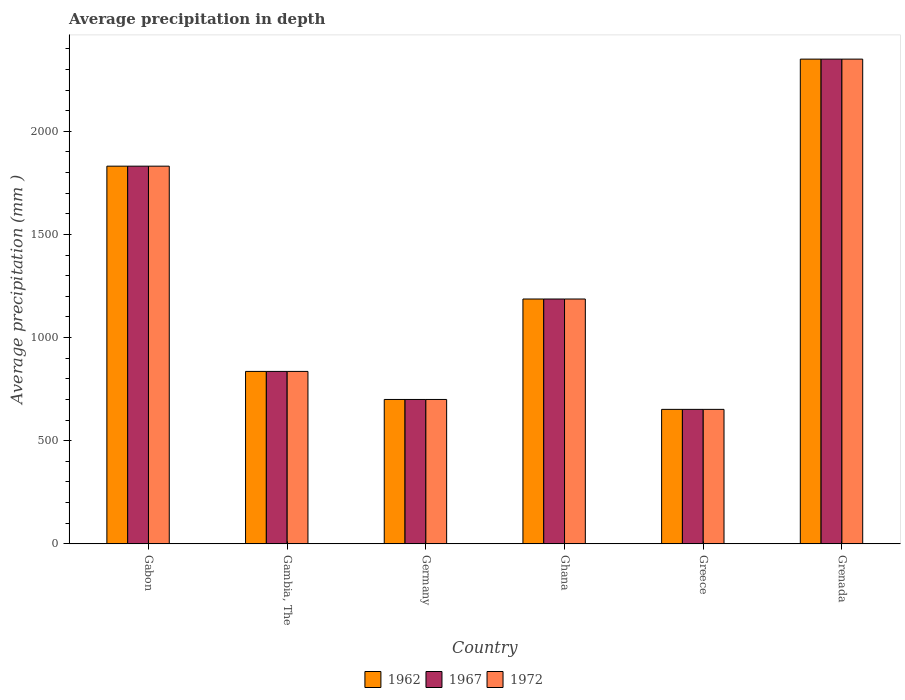How many bars are there on the 1st tick from the left?
Offer a very short reply. 3. How many bars are there on the 1st tick from the right?
Offer a terse response. 3. What is the label of the 3rd group of bars from the left?
Provide a short and direct response. Germany. In how many cases, is the number of bars for a given country not equal to the number of legend labels?
Offer a very short reply. 0. What is the average precipitation in 1972 in Gambia, The?
Ensure brevity in your answer.  836. Across all countries, what is the maximum average precipitation in 1962?
Make the answer very short. 2350. Across all countries, what is the minimum average precipitation in 1967?
Make the answer very short. 652. In which country was the average precipitation in 1967 maximum?
Keep it short and to the point. Grenada. What is the total average precipitation in 1967 in the graph?
Your answer should be very brief. 7556. What is the difference between the average precipitation in 1962 in Greece and that in Grenada?
Provide a succinct answer. -1698. What is the difference between the average precipitation in 1962 in Ghana and the average precipitation in 1967 in Germany?
Provide a succinct answer. 487. What is the average average precipitation in 1972 per country?
Keep it short and to the point. 1259.33. In how many countries, is the average precipitation in 1962 greater than 900 mm?
Offer a very short reply. 3. What is the ratio of the average precipitation in 1962 in Gambia, The to that in Ghana?
Keep it short and to the point. 0.7. Is the average precipitation in 1962 in Gabon less than that in Germany?
Keep it short and to the point. No. What is the difference between the highest and the second highest average precipitation in 1967?
Provide a short and direct response. -1163. What is the difference between the highest and the lowest average precipitation in 1962?
Provide a succinct answer. 1698. What does the 3rd bar from the right in Grenada represents?
Your answer should be compact. 1962. Is it the case that in every country, the sum of the average precipitation in 1962 and average precipitation in 1967 is greater than the average precipitation in 1972?
Your answer should be compact. Yes. How many countries are there in the graph?
Offer a terse response. 6. Are the values on the major ticks of Y-axis written in scientific E-notation?
Offer a very short reply. No. Where does the legend appear in the graph?
Your answer should be very brief. Bottom center. What is the title of the graph?
Offer a very short reply. Average precipitation in depth. What is the label or title of the Y-axis?
Ensure brevity in your answer.  Average precipitation (mm ). What is the Average precipitation (mm ) of 1962 in Gabon?
Provide a short and direct response. 1831. What is the Average precipitation (mm ) of 1967 in Gabon?
Offer a terse response. 1831. What is the Average precipitation (mm ) in 1972 in Gabon?
Offer a very short reply. 1831. What is the Average precipitation (mm ) of 1962 in Gambia, The?
Offer a very short reply. 836. What is the Average precipitation (mm ) in 1967 in Gambia, The?
Your answer should be compact. 836. What is the Average precipitation (mm ) in 1972 in Gambia, The?
Keep it short and to the point. 836. What is the Average precipitation (mm ) in 1962 in Germany?
Your answer should be compact. 700. What is the Average precipitation (mm ) of 1967 in Germany?
Provide a succinct answer. 700. What is the Average precipitation (mm ) in 1972 in Germany?
Ensure brevity in your answer.  700. What is the Average precipitation (mm ) of 1962 in Ghana?
Your response must be concise. 1187. What is the Average precipitation (mm ) of 1967 in Ghana?
Make the answer very short. 1187. What is the Average precipitation (mm ) in 1972 in Ghana?
Give a very brief answer. 1187. What is the Average precipitation (mm ) of 1962 in Greece?
Give a very brief answer. 652. What is the Average precipitation (mm ) of 1967 in Greece?
Your answer should be very brief. 652. What is the Average precipitation (mm ) in 1972 in Greece?
Offer a terse response. 652. What is the Average precipitation (mm ) in 1962 in Grenada?
Make the answer very short. 2350. What is the Average precipitation (mm ) in 1967 in Grenada?
Keep it short and to the point. 2350. What is the Average precipitation (mm ) of 1972 in Grenada?
Offer a terse response. 2350. Across all countries, what is the maximum Average precipitation (mm ) in 1962?
Provide a succinct answer. 2350. Across all countries, what is the maximum Average precipitation (mm ) in 1967?
Provide a short and direct response. 2350. Across all countries, what is the maximum Average precipitation (mm ) in 1972?
Make the answer very short. 2350. Across all countries, what is the minimum Average precipitation (mm ) of 1962?
Keep it short and to the point. 652. Across all countries, what is the minimum Average precipitation (mm ) of 1967?
Give a very brief answer. 652. Across all countries, what is the minimum Average precipitation (mm ) of 1972?
Keep it short and to the point. 652. What is the total Average precipitation (mm ) of 1962 in the graph?
Your response must be concise. 7556. What is the total Average precipitation (mm ) of 1967 in the graph?
Give a very brief answer. 7556. What is the total Average precipitation (mm ) of 1972 in the graph?
Keep it short and to the point. 7556. What is the difference between the Average precipitation (mm ) of 1962 in Gabon and that in Gambia, The?
Provide a succinct answer. 995. What is the difference between the Average precipitation (mm ) in 1967 in Gabon and that in Gambia, The?
Provide a succinct answer. 995. What is the difference between the Average precipitation (mm ) in 1972 in Gabon and that in Gambia, The?
Make the answer very short. 995. What is the difference between the Average precipitation (mm ) of 1962 in Gabon and that in Germany?
Give a very brief answer. 1131. What is the difference between the Average precipitation (mm ) in 1967 in Gabon and that in Germany?
Your answer should be very brief. 1131. What is the difference between the Average precipitation (mm ) of 1972 in Gabon and that in Germany?
Provide a short and direct response. 1131. What is the difference between the Average precipitation (mm ) of 1962 in Gabon and that in Ghana?
Your answer should be very brief. 644. What is the difference between the Average precipitation (mm ) of 1967 in Gabon and that in Ghana?
Your response must be concise. 644. What is the difference between the Average precipitation (mm ) in 1972 in Gabon and that in Ghana?
Offer a terse response. 644. What is the difference between the Average precipitation (mm ) of 1962 in Gabon and that in Greece?
Offer a very short reply. 1179. What is the difference between the Average precipitation (mm ) in 1967 in Gabon and that in Greece?
Offer a terse response. 1179. What is the difference between the Average precipitation (mm ) of 1972 in Gabon and that in Greece?
Offer a very short reply. 1179. What is the difference between the Average precipitation (mm ) in 1962 in Gabon and that in Grenada?
Ensure brevity in your answer.  -519. What is the difference between the Average precipitation (mm ) of 1967 in Gabon and that in Grenada?
Provide a succinct answer. -519. What is the difference between the Average precipitation (mm ) in 1972 in Gabon and that in Grenada?
Make the answer very short. -519. What is the difference between the Average precipitation (mm ) in 1962 in Gambia, The and that in Germany?
Give a very brief answer. 136. What is the difference between the Average precipitation (mm ) in 1967 in Gambia, The and that in Germany?
Offer a terse response. 136. What is the difference between the Average precipitation (mm ) in 1972 in Gambia, The and that in Germany?
Keep it short and to the point. 136. What is the difference between the Average precipitation (mm ) of 1962 in Gambia, The and that in Ghana?
Offer a very short reply. -351. What is the difference between the Average precipitation (mm ) in 1967 in Gambia, The and that in Ghana?
Offer a terse response. -351. What is the difference between the Average precipitation (mm ) of 1972 in Gambia, The and that in Ghana?
Your answer should be very brief. -351. What is the difference between the Average precipitation (mm ) in 1962 in Gambia, The and that in Greece?
Your answer should be compact. 184. What is the difference between the Average precipitation (mm ) of 1967 in Gambia, The and that in Greece?
Your answer should be very brief. 184. What is the difference between the Average precipitation (mm ) of 1972 in Gambia, The and that in Greece?
Keep it short and to the point. 184. What is the difference between the Average precipitation (mm ) of 1962 in Gambia, The and that in Grenada?
Provide a short and direct response. -1514. What is the difference between the Average precipitation (mm ) of 1967 in Gambia, The and that in Grenada?
Keep it short and to the point. -1514. What is the difference between the Average precipitation (mm ) of 1972 in Gambia, The and that in Grenada?
Offer a terse response. -1514. What is the difference between the Average precipitation (mm ) in 1962 in Germany and that in Ghana?
Give a very brief answer. -487. What is the difference between the Average precipitation (mm ) in 1967 in Germany and that in Ghana?
Keep it short and to the point. -487. What is the difference between the Average precipitation (mm ) in 1972 in Germany and that in Ghana?
Your answer should be very brief. -487. What is the difference between the Average precipitation (mm ) of 1962 in Germany and that in Greece?
Make the answer very short. 48. What is the difference between the Average precipitation (mm ) in 1972 in Germany and that in Greece?
Provide a short and direct response. 48. What is the difference between the Average precipitation (mm ) of 1962 in Germany and that in Grenada?
Your response must be concise. -1650. What is the difference between the Average precipitation (mm ) of 1967 in Germany and that in Grenada?
Make the answer very short. -1650. What is the difference between the Average precipitation (mm ) in 1972 in Germany and that in Grenada?
Keep it short and to the point. -1650. What is the difference between the Average precipitation (mm ) of 1962 in Ghana and that in Greece?
Ensure brevity in your answer.  535. What is the difference between the Average precipitation (mm ) of 1967 in Ghana and that in Greece?
Give a very brief answer. 535. What is the difference between the Average precipitation (mm ) in 1972 in Ghana and that in Greece?
Ensure brevity in your answer.  535. What is the difference between the Average precipitation (mm ) in 1962 in Ghana and that in Grenada?
Provide a short and direct response. -1163. What is the difference between the Average precipitation (mm ) of 1967 in Ghana and that in Grenada?
Offer a terse response. -1163. What is the difference between the Average precipitation (mm ) of 1972 in Ghana and that in Grenada?
Give a very brief answer. -1163. What is the difference between the Average precipitation (mm ) of 1962 in Greece and that in Grenada?
Your response must be concise. -1698. What is the difference between the Average precipitation (mm ) of 1967 in Greece and that in Grenada?
Give a very brief answer. -1698. What is the difference between the Average precipitation (mm ) in 1972 in Greece and that in Grenada?
Your answer should be very brief. -1698. What is the difference between the Average precipitation (mm ) in 1962 in Gabon and the Average precipitation (mm ) in 1967 in Gambia, The?
Offer a very short reply. 995. What is the difference between the Average precipitation (mm ) in 1962 in Gabon and the Average precipitation (mm ) in 1972 in Gambia, The?
Provide a short and direct response. 995. What is the difference between the Average precipitation (mm ) in 1967 in Gabon and the Average precipitation (mm ) in 1972 in Gambia, The?
Provide a succinct answer. 995. What is the difference between the Average precipitation (mm ) in 1962 in Gabon and the Average precipitation (mm ) in 1967 in Germany?
Make the answer very short. 1131. What is the difference between the Average precipitation (mm ) of 1962 in Gabon and the Average precipitation (mm ) of 1972 in Germany?
Give a very brief answer. 1131. What is the difference between the Average precipitation (mm ) of 1967 in Gabon and the Average precipitation (mm ) of 1972 in Germany?
Provide a succinct answer. 1131. What is the difference between the Average precipitation (mm ) in 1962 in Gabon and the Average precipitation (mm ) in 1967 in Ghana?
Provide a short and direct response. 644. What is the difference between the Average precipitation (mm ) of 1962 in Gabon and the Average precipitation (mm ) of 1972 in Ghana?
Offer a terse response. 644. What is the difference between the Average precipitation (mm ) of 1967 in Gabon and the Average precipitation (mm ) of 1972 in Ghana?
Provide a succinct answer. 644. What is the difference between the Average precipitation (mm ) of 1962 in Gabon and the Average precipitation (mm ) of 1967 in Greece?
Your answer should be compact. 1179. What is the difference between the Average precipitation (mm ) of 1962 in Gabon and the Average precipitation (mm ) of 1972 in Greece?
Give a very brief answer. 1179. What is the difference between the Average precipitation (mm ) of 1967 in Gabon and the Average precipitation (mm ) of 1972 in Greece?
Your answer should be very brief. 1179. What is the difference between the Average precipitation (mm ) in 1962 in Gabon and the Average precipitation (mm ) in 1967 in Grenada?
Provide a short and direct response. -519. What is the difference between the Average precipitation (mm ) of 1962 in Gabon and the Average precipitation (mm ) of 1972 in Grenada?
Give a very brief answer. -519. What is the difference between the Average precipitation (mm ) of 1967 in Gabon and the Average precipitation (mm ) of 1972 in Grenada?
Give a very brief answer. -519. What is the difference between the Average precipitation (mm ) in 1962 in Gambia, The and the Average precipitation (mm ) in 1967 in Germany?
Provide a succinct answer. 136. What is the difference between the Average precipitation (mm ) of 1962 in Gambia, The and the Average precipitation (mm ) of 1972 in Germany?
Your answer should be compact. 136. What is the difference between the Average precipitation (mm ) in 1967 in Gambia, The and the Average precipitation (mm ) in 1972 in Germany?
Make the answer very short. 136. What is the difference between the Average precipitation (mm ) of 1962 in Gambia, The and the Average precipitation (mm ) of 1967 in Ghana?
Your response must be concise. -351. What is the difference between the Average precipitation (mm ) in 1962 in Gambia, The and the Average precipitation (mm ) in 1972 in Ghana?
Your answer should be very brief. -351. What is the difference between the Average precipitation (mm ) in 1967 in Gambia, The and the Average precipitation (mm ) in 1972 in Ghana?
Make the answer very short. -351. What is the difference between the Average precipitation (mm ) in 1962 in Gambia, The and the Average precipitation (mm ) in 1967 in Greece?
Your answer should be very brief. 184. What is the difference between the Average precipitation (mm ) of 1962 in Gambia, The and the Average precipitation (mm ) of 1972 in Greece?
Offer a very short reply. 184. What is the difference between the Average precipitation (mm ) of 1967 in Gambia, The and the Average precipitation (mm ) of 1972 in Greece?
Your answer should be compact. 184. What is the difference between the Average precipitation (mm ) of 1962 in Gambia, The and the Average precipitation (mm ) of 1967 in Grenada?
Offer a terse response. -1514. What is the difference between the Average precipitation (mm ) in 1962 in Gambia, The and the Average precipitation (mm ) in 1972 in Grenada?
Give a very brief answer. -1514. What is the difference between the Average precipitation (mm ) in 1967 in Gambia, The and the Average precipitation (mm ) in 1972 in Grenada?
Ensure brevity in your answer.  -1514. What is the difference between the Average precipitation (mm ) of 1962 in Germany and the Average precipitation (mm ) of 1967 in Ghana?
Ensure brevity in your answer.  -487. What is the difference between the Average precipitation (mm ) of 1962 in Germany and the Average precipitation (mm ) of 1972 in Ghana?
Your response must be concise. -487. What is the difference between the Average precipitation (mm ) in 1967 in Germany and the Average precipitation (mm ) in 1972 in Ghana?
Your response must be concise. -487. What is the difference between the Average precipitation (mm ) of 1962 in Germany and the Average precipitation (mm ) of 1967 in Greece?
Provide a short and direct response. 48. What is the difference between the Average precipitation (mm ) of 1967 in Germany and the Average precipitation (mm ) of 1972 in Greece?
Give a very brief answer. 48. What is the difference between the Average precipitation (mm ) of 1962 in Germany and the Average precipitation (mm ) of 1967 in Grenada?
Provide a succinct answer. -1650. What is the difference between the Average precipitation (mm ) of 1962 in Germany and the Average precipitation (mm ) of 1972 in Grenada?
Your response must be concise. -1650. What is the difference between the Average precipitation (mm ) of 1967 in Germany and the Average precipitation (mm ) of 1972 in Grenada?
Give a very brief answer. -1650. What is the difference between the Average precipitation (mm ) of 1962 in Ghana and the Average precipitation (mm ) of 1967 in Greece?
Your response must be concise. 535. What is the difference between the Average precipitation (mm ) of 1962 in Ghana and the Average precipitation (mm ) of 1972 in Greece?
Keep it short and to the point. 535. What is the difference between the Average precipitation (mm ) in 1967 in Ghana and the Average precipitation (mm ) in 1972 in Greece?
Make the answer very short. 535. What is the difference between the Average precipitation (mm ) in 1962 in Ghana and the Average precipitation (mm ) in 1967 in Grenada?
Offer a terse response. -1163. What is the difference between the Average precipitation (mm ) of 1962 in Ghana and the Average precipitation (mm ) of 1972 in Grenada?
Your answer should be very brief. -1163. What is the difference between the Average precipitation (mm ) in 1967 in Ghana and the Average precipitation (mm ) in 1972 in Grenada?
Provide a short and direct response. -1163. What is the difference between the Average precipitation (mm ) in 1962 in Greece and the Average precipitation (mm ) in 1967 in Grenada?
Provide a short and direct response. -1698. What is the difference between the Average precipitation (mm ) of 1962 in Greece and the Average precipitation (mm ) of 1972 in Grenada?
Give a very brief answer. -1698. What is the difference between the Average precipitation (mm ) of 1967 in Greece and the Average precipitation (mm ) of 1972 in Grenada?
Provide a succinct answer. -1698. What is the average Average precipitation (mm ) in 1962 per country?
Keep it short and to the point. 1259.33. What is the average Average precipitation (mm ) in 1967 per country?
Your response must be concise. 1259.33. What is the average Average precipitation (mm ) in 1972 per country?
Provide a succinct answer. 1259.33. What is the difference between the Average precipitation (mm ) of 1962 and Average precipitation (mm ) of 1967 in Gabon?
Offer a terse response. 0. What is the difference between the Average precipitation (mm ) in 1967 and Average precipitation (mm ) in 1972 in Gabon?
Make the answer very short. 0. What is the difference between the Average precipitation (mm ) of 1962 and Average precipitation (mm ) of 1967 in Gambia, The?
Ensure brevity in your answer.  0. What is the difference between the Average precipitation (mm ) of 1967 and Average precipitation (mm ) of 1972 in Gambia, The?
Ensure brevity in your answer.  0. What is the difference between the Average precipitation (mm ) of 1962 and Average precipitation (mm ) of 1972 in Germany?
Offer a terse response. 0. What is the difference between the Average precipitation (mm ) of 1962 and Average precipitation (mm ) of 1967 in Ghana?
Provide a succinct answer. 0. What is the difference between the Average precipitation (mm ) in 1962 and Average precipitation (mm ) in 1972 in Ghana?
Provide a short and direct response. 0. What is the difference between the Average precipitation (mm ) of 1967 and Average precipitation (mm ) of 1972 in Greece?
Your answer should be compact. 0. What is the difference between the Average precipitation (mm ) of 1962 and Average precipitation (mm ) of 1967 in Grenada?
Your response must be concise. 0. What is the difference between the Average precipitation (mm ) in 1967 and Average precipitation (mm ) in 1972 in Grenada?
Make the answer very short. 0. What is the ratio of the Average precipitation (mm ) in 1962 in Gabon to that in Gambia, The?
Your response must be concise. 2.19. What is the ratio of the Average precipitation (mm ) in 1967 in Gabon to that in Gambia, The?
Provide a short and direct response. 2.19. What is the ratio of the Average precipitation (mm ) of 1972 in Gabon to that in Gambia, The?
Make the answer very short. 2.19. What is the ratio of the Average precipitation (mm ) in 1962 in Gabon to that in Germany?
Your answer should be very brief. 2.62. What is the ratio of the Average precipitation (mm ) of 1967 in Gabon to that in Germany?
Your response must be concise. 2.62. What is the ratio of the Average precipitation (mm ) in 1972 in Gabon to that in Germany?
Your answer should be very brief. 2.62. What is the ratio of the Average precipitation (mm ) in 1962 in Gabon to that in Ghana?
Make the answer very short. 1.54. What is the ratio of the Average precipitation (mm ) in 1967 in Gabon to that in Ghana?
Make the answer very short. 1.54. What is the ratio of the Average precipitation (mm ) of 1972 in Gabon to that in Ghana?
Provide a succinct answer. 1.54. What is the ratio of the Average precipitation (mm ) of 1962 in Gabon to that in Greece?
Make the answer very short. 2.81. What is the ratio of the Average precipitation (mm ) of 1967 in Gabon to that in Greece?
Make the answer very short. 2.81. What is the ratio of the Average precipitation (mm ) in 1972 in Gabon to that in Greece?
Your answer should be compact. 2.81. What is the ratio of the Average precipitation (mm ) of 1962 in Gabon to that in Grenada?
Your answer should be very brief. 0.78. What is the ratio of the Average precipitation (mm ) in 1967 in Gabon to that in Grenada?
Your answer should be very brief. 0.78. What is the ratio of the Average precipitation (mm ) of 1972 in Gabon to that in Grenada?
Provide a short and direct response. 0.78. What is the ratio of the Average precipitation (mm ) in 1962 in Gambia, The to that in Germany?
Make the answer very short. 1.19. What is the ratio of the Average precipitation (mm ) in 1967 in Gambia, The to that in Germany?
Make the answer very short. 1.19. What is the ratio of the Average precipitation (mm ) of 1972 in Gambia, The to that in Germany?
Provide a short and direct response. 1.19. What is the ratio of the Average precipitation (mm ) in 1962 in Gambia, The to that in Ghana?
Your response must be concise. 0.7. What is the ratio of the Average precipitation (mm ) in 1967 in Gambia, The to that in Ghana?
Provide a short and direct response. 0.7. What is the ratio of the Average precipitation (mm ) in 1972 in Gambia, The to that in Ghana?
Ensure brevity in your answer.  0.7. What is the ratio of the Average precipitation (mm ) in 1962 in Gambia, The to that in Greece?
Your answer should be compact. 1.28. What is the ratio of the Average precipitation (mm ) in 1967 in Gambia, The to that in Greece?
Your answer should be compact. 1.28. What is the ratio of the Average precipitation (mm ) of 1972 in Gambia, The to that in Greece?
Give a very brief answer. 1.28. What is the ratio of the Average precipitation (mm ) in 1962 in Gambia, The to that in Grenada?
Give a very brief answer. 0.36. What is the ratio of the Average precipitation (mm ) of 1967 in Gambia, The to that in Grenada?
Offer a very short reply. 0.36. What is the ratio of the Average precipitation (mm ) of 1972 in Gambia, The to that in Grenada?
Keep it short and to the point. 0.36. What is the ratio of the Average precipitation (mm ) of 1962 in Germany to that in Ghana?
Make the answer very short. 0.59. What is the ratio of the Average precipitation (mm ) of 1967 in Germany to that in Ghana?
Your response must be concise. 0.59. What is the ratio of the Average precipitation (mm ) of 1972 in Germany to that in Ghana?
Offer a very short reply. 0.59. What is the ratio of the Average precipitation (mm ) in 1962 in Germany to that in Greece?
Provide a short and direct response. 1.07. What is the ratio of the Average precipitation (mm ) of 1967 in Germany to that in Greece?
Your answer should be compact. 1.07. What is the ratio of the Average precipitation (mm ) in 1972 in Germany to that in Greece?
Offer a terse response. 1.07. What is the ratio of the Average precipitation (mm ) in 1962 in Germany to that in Grenada?
Offer a terse response. 0.3. What is the ratio of the Average precipitation (mm ) in 1967 in Germany to that in Grenada?
Give a very brief answer. 0.3. What is the ratio of the Average precipitation (mm ) of 1972 in Germany to that in Grenada?
Give a very brief answer. 0.3. What is the ratio of the Average precipitation (mm ) in 1962 in Ghana to that in Greece?
Make the answer very short. 1.82. What is the ratio of the Average precipitation (mm ) in 1967 in Ghana to that in Greece?
Your answer should be very brief. 1.82. What is the ratio of the Average precipitation (mm ) in 1972 in Ghana to that in Greece?
Provide a succinct answer. 1.82. What is the ratio of the Average precipitation (mm ) of 1962 in Ghana to that in Grenada?
Provide a succinct answer. 0.51. What is the ratio of the Average precipitation (mm ) of 1967 in Ghana to that in Grenada?
Offer a terse response. 0.51. What is the ratio of the Average precipitation (mm ) in 1972 in Ghana to that in Grenada?
Offer a terse response. 0.51. What is the ratio of the Average precipitation (mm ) of 1962 in Greece to that in Grenada?
Keep it short and to the point. 0.28. What is the ratio of the Average precipitation (mm ) of 1967 in Greece to that in Grenada?
Ensure brevity in your answer.  0.28. What is the ratio of the Average precipitation (mm ) in 1972 in Greece to that in Grenada?
Your answer should be compact. 0.28. What is the difference between the highest and the second highest Average precipitation (mm ) in 1962?
Offer a very short reply. 519. What is the difference between the highest and the second highest Average precipitation (mm ) of 1967?
Make the answer very short. 519. What is the difference between the highest and the second highest Average precipitation (mm ) of 1972?
Give a very brief answer. 519. What is the difference between the highest and the lowest Average precipitation (mm ) in 1962?
Keep it short and to the point. 1698. What is the difference between the highest and the lowest Average precipitation (mm ) in 1967?
Provide a succinct answer. 1698. What is the difference between the highest and the lowest Average precipitation (mm ) in 1972?
Provide a succinct answer. 1698. 